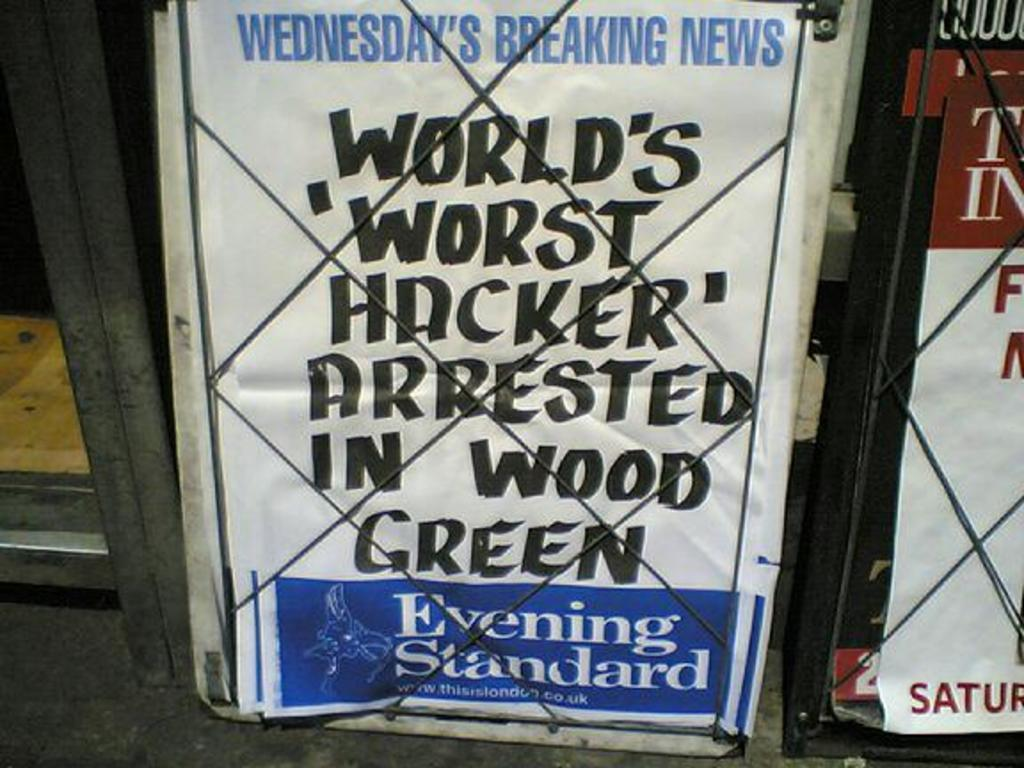<image>
Summarize the visual content of the image. Poster that reads " World's "Worst Hacker" arrested in Wood Green" 